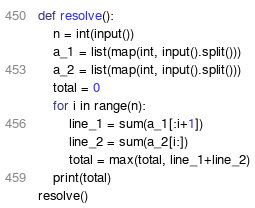<code> <loc_0><loc_0><loc_500><loc_500><_Python_>def resolve():
    n = int(input())
    a_1 = list(map(int, input().split()))
    a_2 = list(map(int, input().split()))
    total = 0
    for i in range(n):
        line_1 = sum(a_1[:i+1])
        line_2 = sum(a_2[i:])
        total = max(total, line_1+line_2)
    print(total)
resolve()</code> 